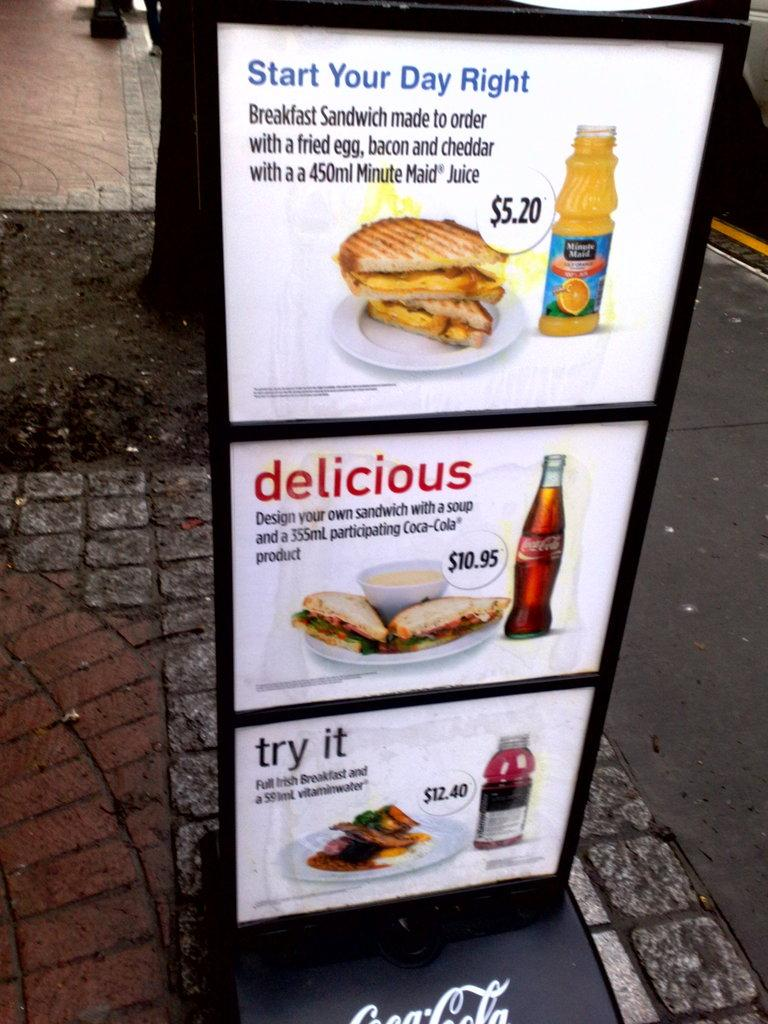What is the main subject of the image? The main subject of the image is a board with pictures. What type of items are depicted on the board? The board contains food items. Is there any text on the board? Yes, there is text on the board. Where is the board located in the image? The board is placed on the ground. What can be seen in the background of the image? There are trees and a vehicle in the background of the image. What time does the class start in the image? There is no indication of a class or time in the image; it features a board with food items and text on the ground. What trick is being performed with the vehicle in the background? There is no trick being performed with the vehicle in the background; it is simply visible in the image. 